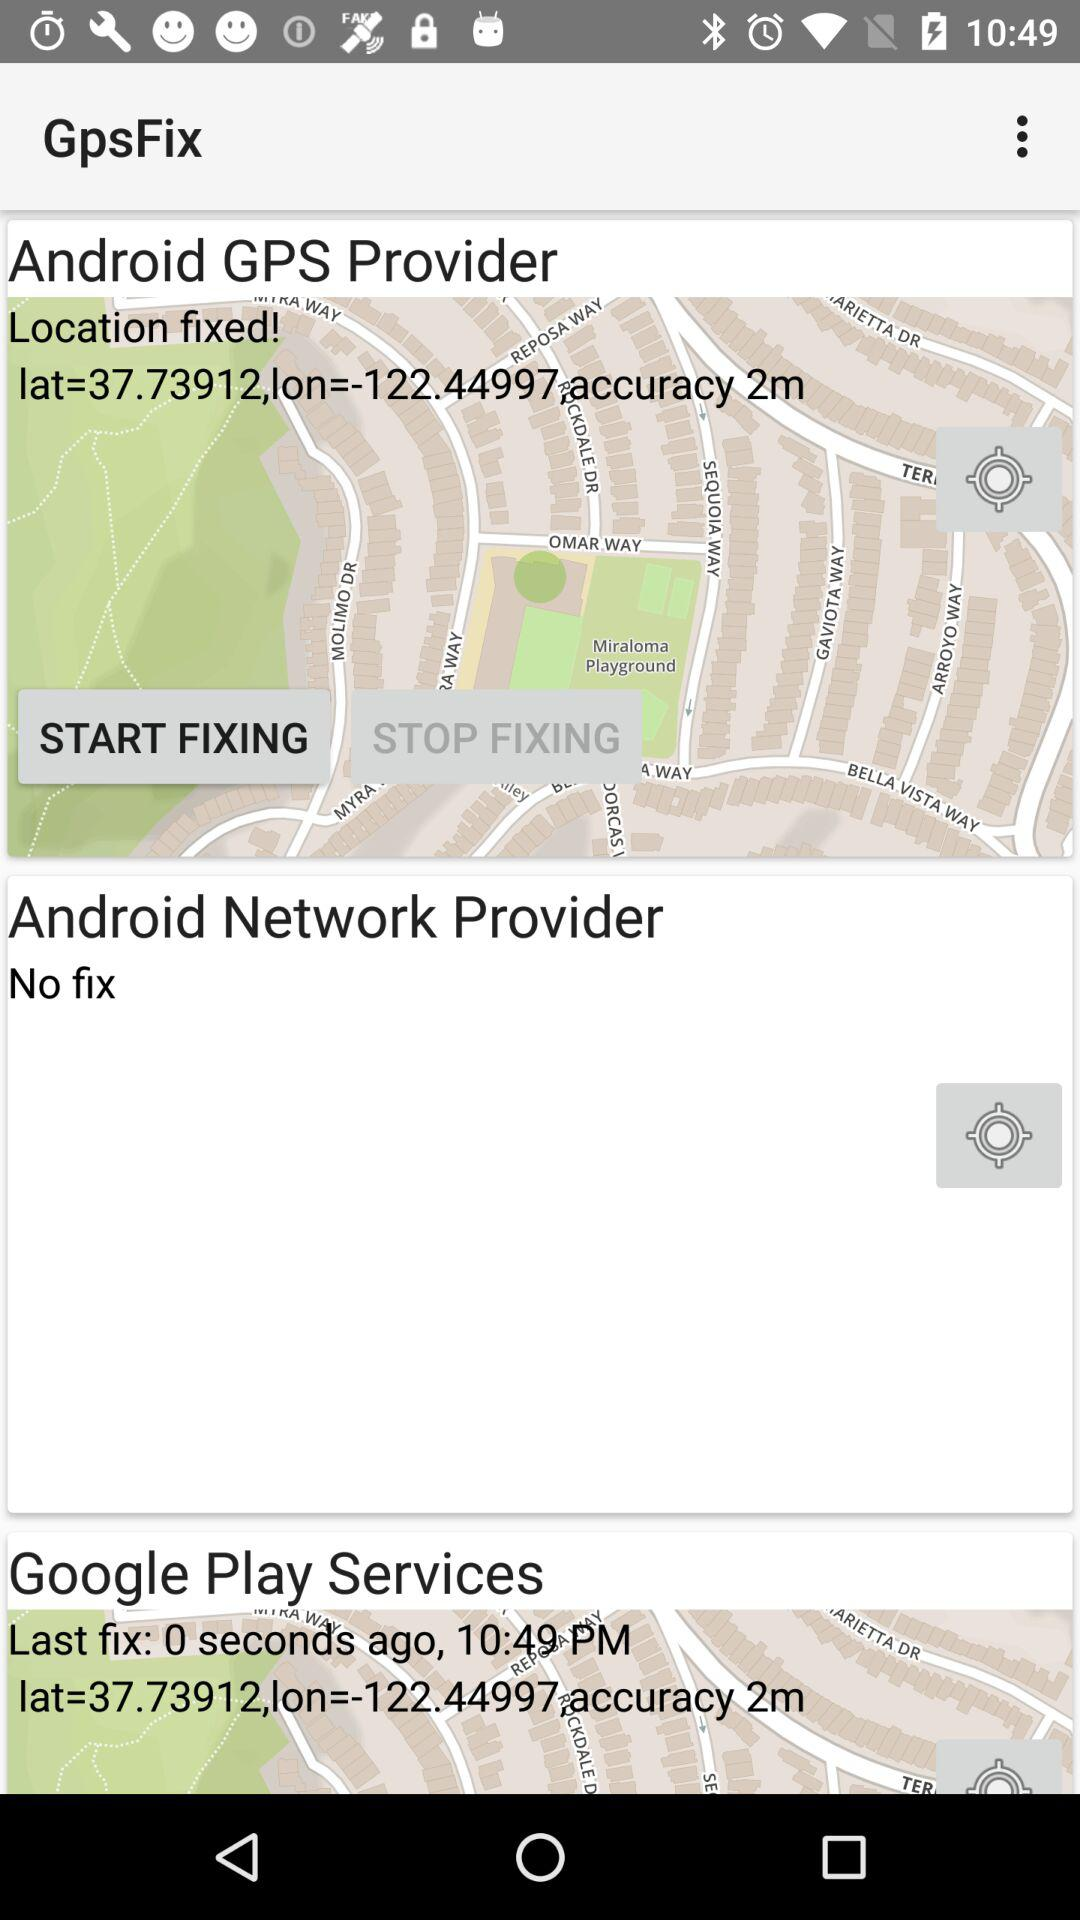What is the application name? The application name is "GpsFix". 